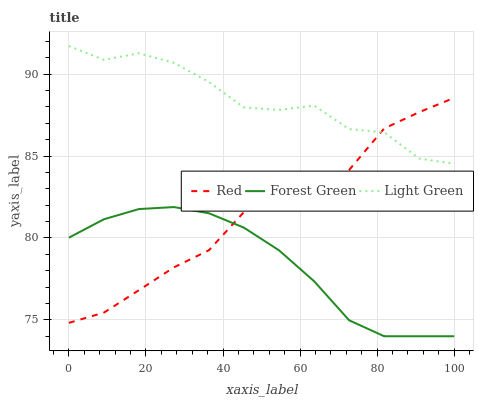Does Forest Green have the minimum area under the curve?
Answer yes or no. Yes. Does Light Green have the maximum area under the curve?
Answer yes or no. Yes. Does Red have the minimum area under the curve?
Answer yes or no. No. Does Red have the maximum area under the curve?
Answer yes or no. No. Is Forest Green the smoothest?
Answer yes or no. Yes. Is Light Green the roughest?
Answer yes or no. Yes. Is Red the smoothest?
Answer yes or no. No. Is Red the roughest?
Answer yes or no. No. Does Forest Green have the lowest value?
Answer yes or no. Yes. Does Red have the lowest value?
Answer yes or no. No. Does Light Green have the highest value?
Answer yes or no. Yes. Does Red have the highest value?
Answer yes or no. No. Is Forest Green less than Light Green?
Answer yes or no. Yes. Is Light Green greater than Forest Green?
Answer yes or no. Yes. Does Light Green intersect Red?
Answer yes or no. Yes. Is Light Green less than Red?
Answer yes or no. No. Is Light Green greater than Red?
Answer yes or no. No. Does Forest Green intersect Light Green?
Answer yes or no. No. 